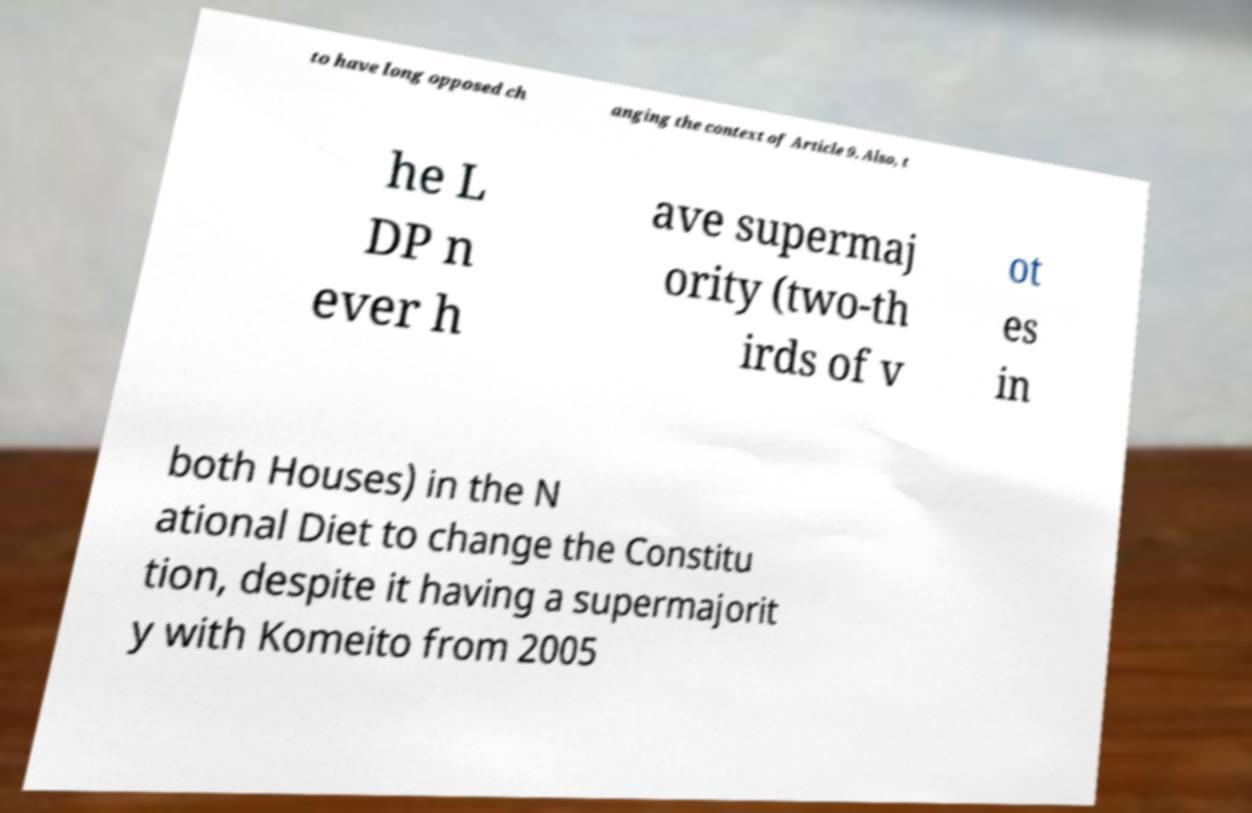There's text embedded in this image that I need extracted. Can you transcribe it verbatim? to have long opposed ch anging the context of Article 9. Also, t he L DP n ever h ave supermaj ority (two-th irds of v ot es in both Houses) in the N ational Diet to change the Constitu tion, despite it having a supermajorit y with Komeito from 2005 